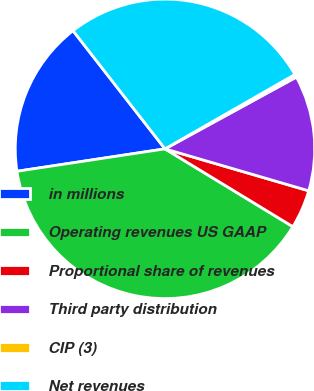Convert chart. <chart><loc_0><loc_0><loc_500><loc_500><pie_chart><fcel>in millions<fcel>Operating revenues US GAAP<fcel>Proportional share of revenues<fcel>Third party distribution<fcel>CIP (3)<fcel>Net revenues<nl><fcel>16.87%<fcel>38.91%<fcel>4.18%<fcel>12.48%<fcel>0.32%<fcel>27.25%<nl></chart> 